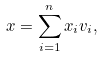Convert formula to latex. <formula><loc_0><loc_0><loc_500><loc_500>x = \sum _ { i = 1 } ^ { n } x _ { i } v _ { i } ,</formula> 